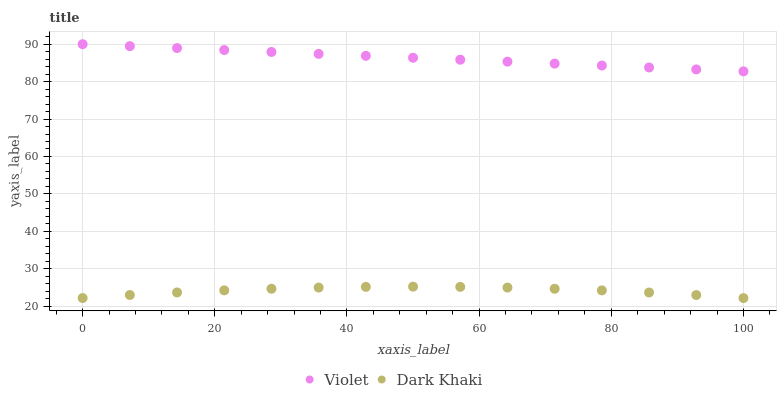Does Dark Khaki have the minimum area under the curve?
Answer yes or no. Yes. Does Violet have the maximum area under the curve?
Answer yes or no. Yes. Does Violet have the minimum area under the curve?
Answer yes or no. No. Is Violet the smoothest?
Answer yes or no. Yes. Is Dark Khaki the roughest?
Answer yes or no. Yes. Is Violet the roughest?
Answer yes or no. No. Does Dark Khaki have the lowest value?
Answer yes or no. Yes. Does Violet have the lowest value?
Answer yes or no. No. Does Violet have the highest value?
Answer yes or no. Yes. Is Dark Khaki less than Violet?
Answer yes or no. Yes. Is Violet greater than Dark Khaki?
Answer yes or no. Yes. Does Dark Khaki intersect Violet?
Answer yes or no. No. 